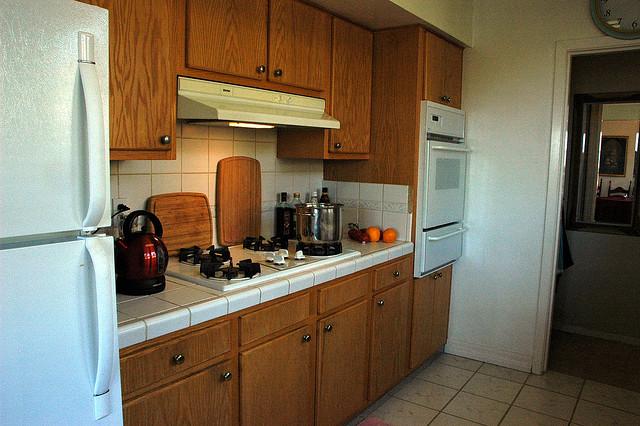Are the stove and oven one appliance?
Answer briefly. No. What are the fruits in this picture?
Quick response, please. Oranges. What room in the house is this?
Concise answer only. Kitchen. How many unused spots are on the stovetop?
Concise answer only. 3. 